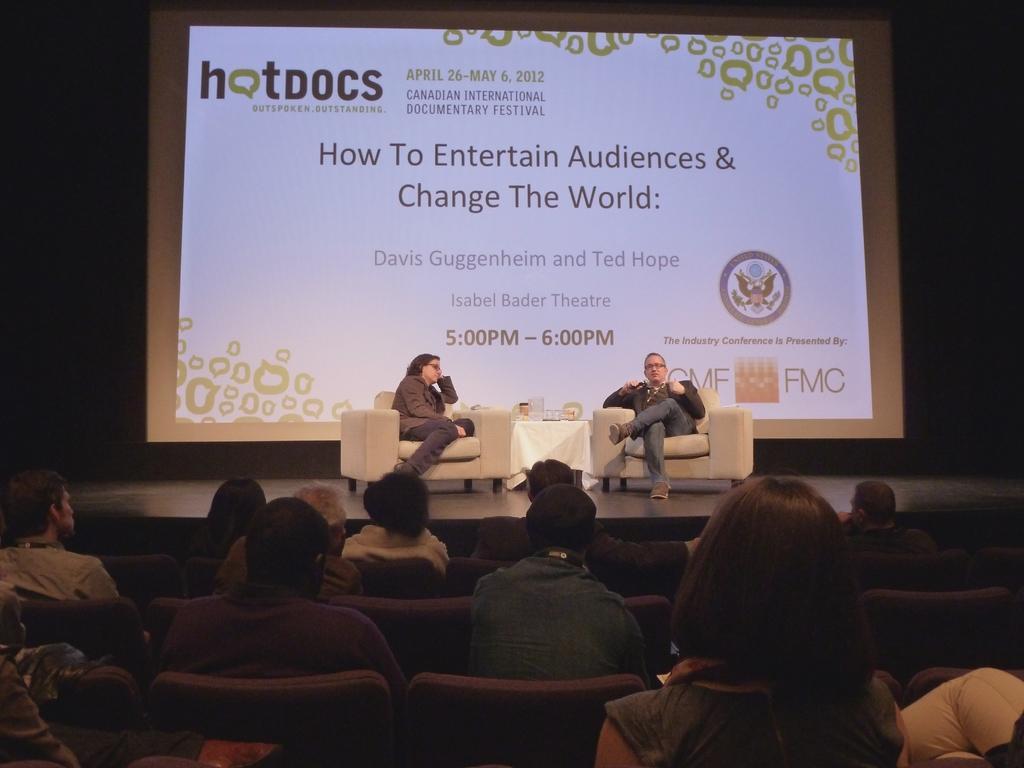Could you give a brief overview of what you see in this image? There is a stage. On the stage there are two persons sitting on chairs. Near to that there is a table with a white cloth. On that there are some items. In the back there is a screen with something written on that. In front of the stage there are many people sitting on the chairs. 